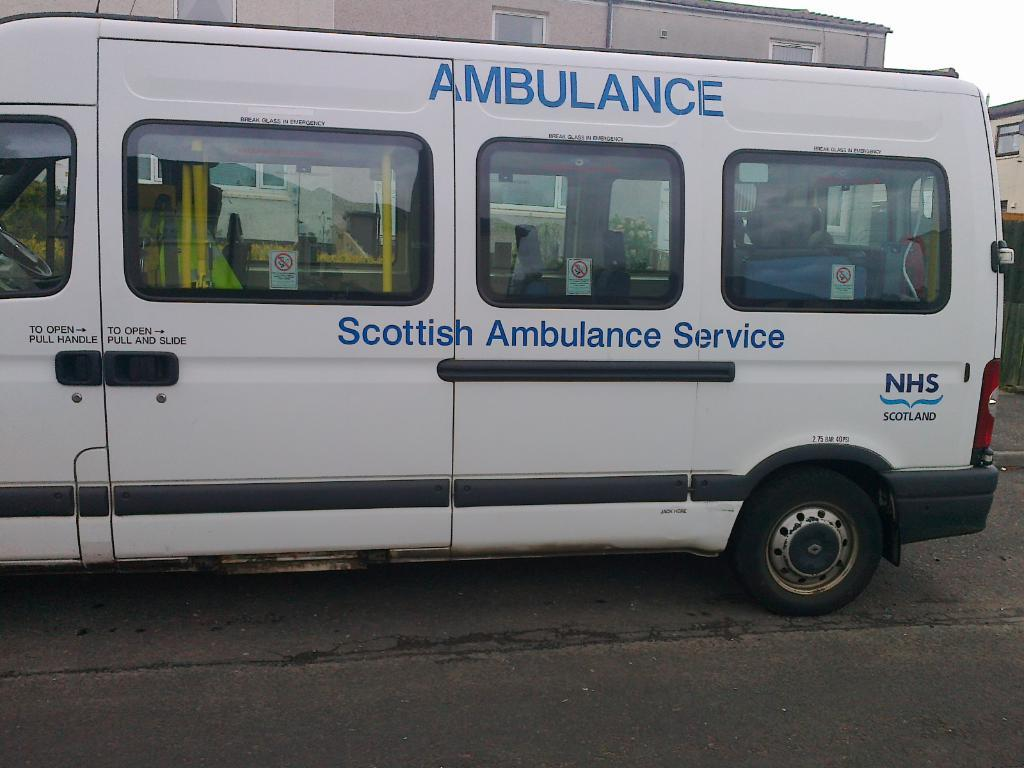<image>
Give a short and clear explanation of the subsequent image. A white van that says Scottish Ambulance Service. 